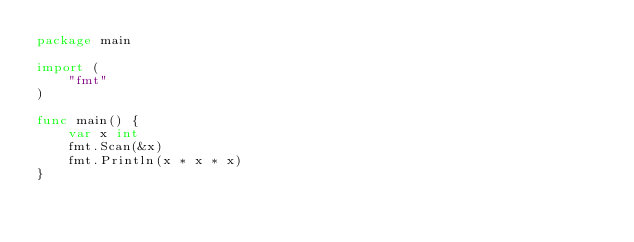<code> <loc_0><loc_0><loc_500><loc_500><_Go_>package main

import (
	"fmt"
)

func main() {
	var x int
	fmt.Scan(&x)
	fmt.Println(x * x * x)
}

</code> 